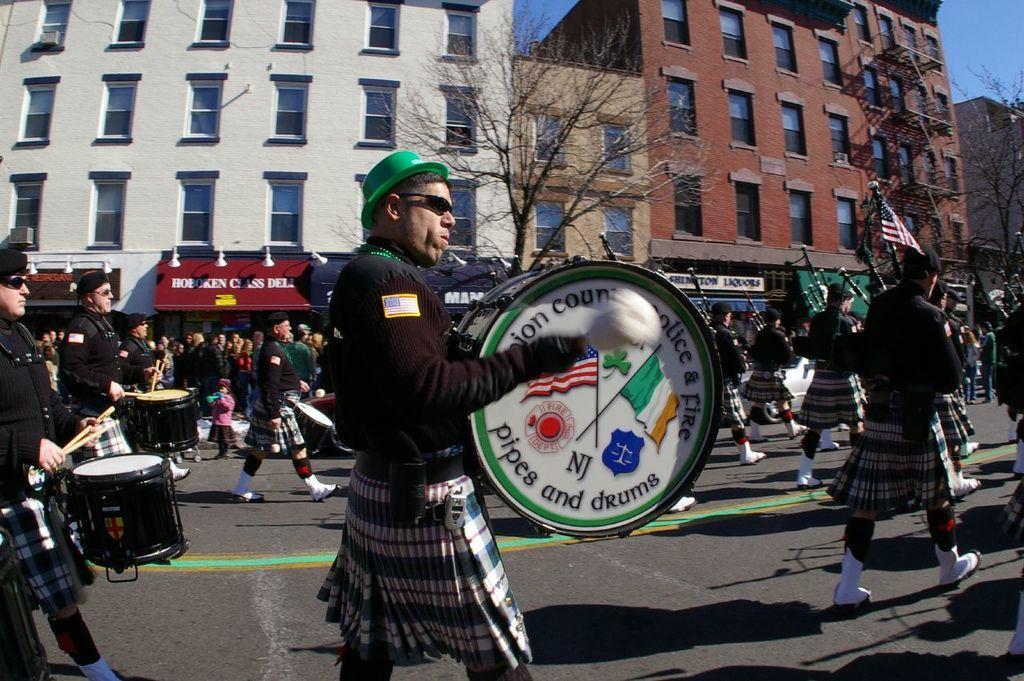How would you summarize this image in a sentence or two? In this image I can see the group of people walking. Among them some people are playing drum set. At the back there is a tree and the building. 